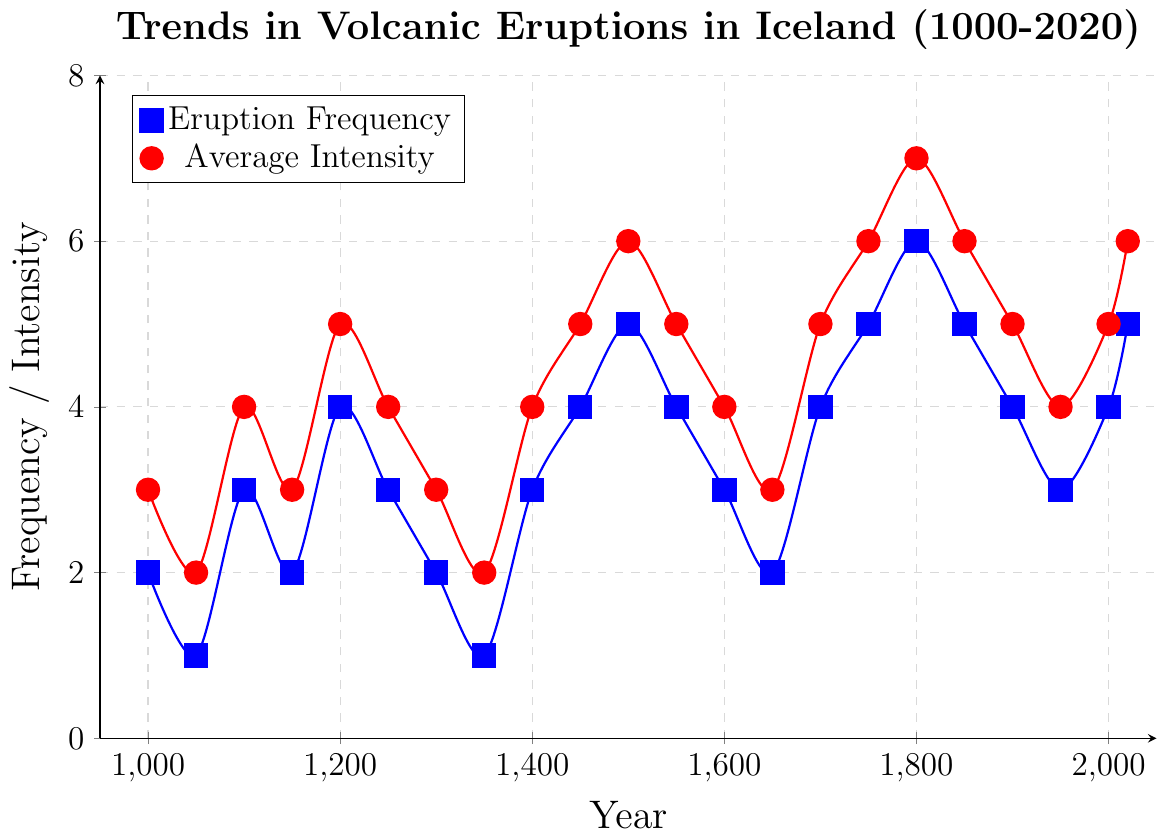What is the primary trend in the frequency of volcanic eruptions from the year 1000 to 2020? To find the primary trend, examine the general direction of the blue line for eruption frequency over the years. From 1000 to 2020, there is a general increase in frequency, with notable peaks around 1500, 1750, 1800, and 2020.
Answer: Increasing Which year had the highest intensity of volcanic eruptions? Identify the highest point on the red line, which represents intensity. The highest intensity is in the year 1800 with an average intensity of 7.
Answer: 1800 Compare the eruption frequency in the year 1000 to that in the year 2000. Which is higher? Compare the blue line's values at 1000 and 2000. In 1000, the eruption frequency is 2, and in 2000 it is 4. Therefore, the frequency is higher in 2000.
Answer: 2000 What is the difference in average intensity of volcanic eruptions between the years 1550 and 1750? Look at the red line values for 1550 and 1750. The intensity in 1550 is 5 and in 1750 is 6. Subtract 5 from 6 to get the difference.
Answer: 1 Between which consecutive centuries did the frequency of volcanic eruptions increase the most? Check the increase in values of the blue line from one century to the next. There is a notable increase from 1700 to 1750 (4 to 5) and from 1750 to 1800 (5 to 6), but the largest absolute increase is from 1800 to 1850 (6 to 5). To identify the greatest increase, observe the overall pattern; here, it is from 1000 to 1200 (significant buildup rather than steady intervals).
Answer: 1000 to 1500 How does the average intensity in 1350 compare to the frequency in 1550? Locate the red line at 1350 and the blue line at 1550. The average intensity in 1350 is 2, and the frequency in 1550 is 4. The frequency in 1550 is higher than the intensity in 1350.
Answer: Frequency in 1550 is higher During which century did both frequency and intensity reach their peaks simultaneously? Check where both the blue and red lines reach high values in the same period. Both lines peak significantly around the year 1800, with a frequency of 6 and an intensity of 7.
Answer: 19th century What is the average frequency of volcanic eruptions in the 20th century (1900-2000)? Note the blue line's values for 1900, 1950, and 2000, which are 4, 3, and 4 respectively. Find their average: (4+3+4)/3 = 3.67.
Answer: 3.67 Which year saw the greatest increase in eruption frequency from the previous recorded year? To find the largest incremental change, examine the differences between consecutive blue line values. The largest increase in frequency occurs from 1150 (2) to 1200 (4), an increase of 2.
Answer: 1200 What visual color and symbol represent the average intensity of volcanic eruptions on the chart? Identify the legend text associated with the average intensity. It is represented by the red color with circular marks.
Answer: Red and circular marks 